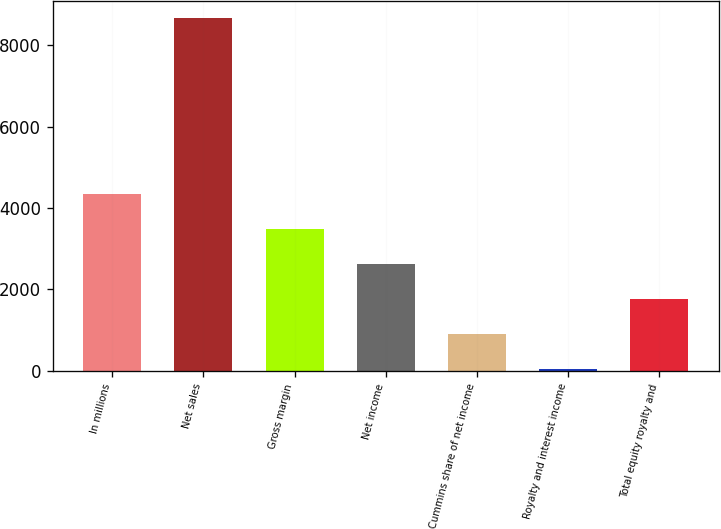Convert chart to OTSL. <chart><loc_0><loc_0><loc_500><loc_500><bar_chart><fcel>In millions<fcel>Net sales<fcel>Gross margin<fcel>Net income<fcel>Cummins share of net income<fcel>Royalty and interest income<fcel>Total equity royalty and<nl><fcel>4350<fcel>8659<fcel>3488.2<fcel>2626.4<fcel>902.8<fcel>41<fcel>1764.6<nl></chart> 